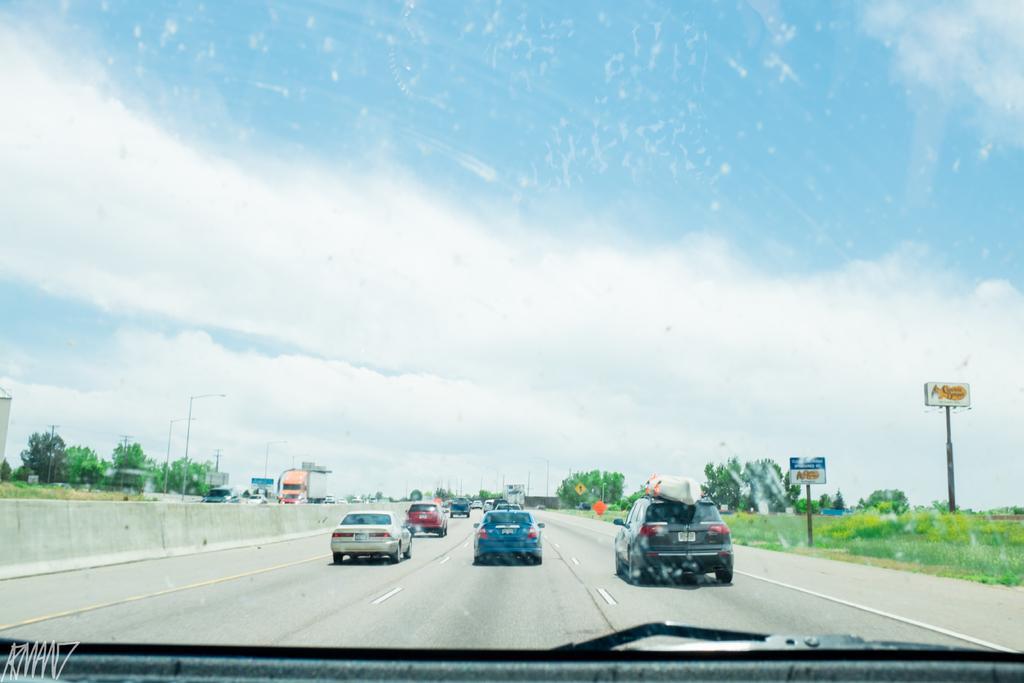In one or two sentences, can you explain what this image depicts? There are cars on the road and grassland in the foreground area of the image, there are trees, poles, vehicles and sky in the background, it seems like a car at the bottom side. 